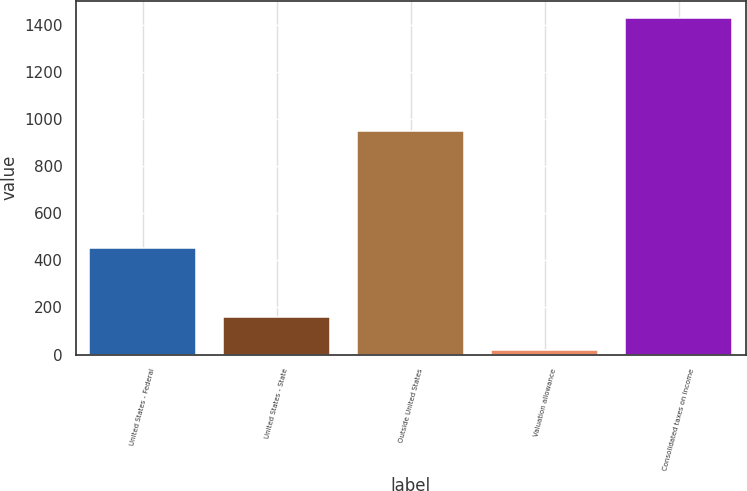Convert chart to OTSL. <chart><loc_0><loc_0><loc_500><loc_500><bar_chart><fcel>United States - Federal<fcel>United States - State<fcel>Outside United States<fcel>Valuation allowance<fcel>Consolidated taxes on income<nl><fcel>453<fcel>159.2<fcel>949<fcel>18<fcel>1430<nl></chart> 